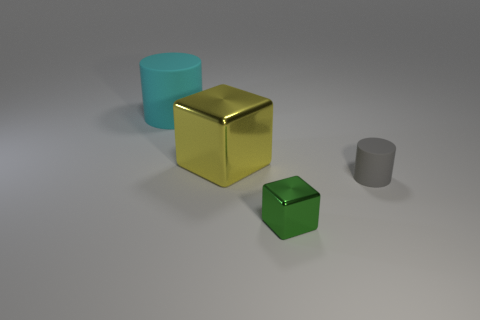There is a cylinder left of the block that is in front of the tiny gray rubber cylinder; what is its color?
Offer a terse response. Cyan. What shape is the tiny green object?
Ensure brevity in your answer.  Cube. The object that is both in front of the large cyan object and behind the tiny cylinder has what shape?
Make the answer very short. Cube. The small object that is the same material as the large cyan thing is what color?
Give a very brief answer. Gray. The large cyan rubber thing behind the block that is behind the matte thing in front of the big cylinder is what shape?
Make the answer very short. Cylinder. What is the size of the yellow object?
Give a very brief answer. Large. There is a green object that is the same material as the large yellow object; what is its shape?
Your answer should be compact. Cube. Are there fewer big shiny blocks to the right of the gray matte cylinder than red rubber spheres?
Ensure brevity in your answer.  No. What color is the rubber object to the right of the tiny shiny block?
Your response must be concise. Gray. Are there any tiny blue objects that have the same shape as the yellow shiny object?
Offer a very short reply. No. 